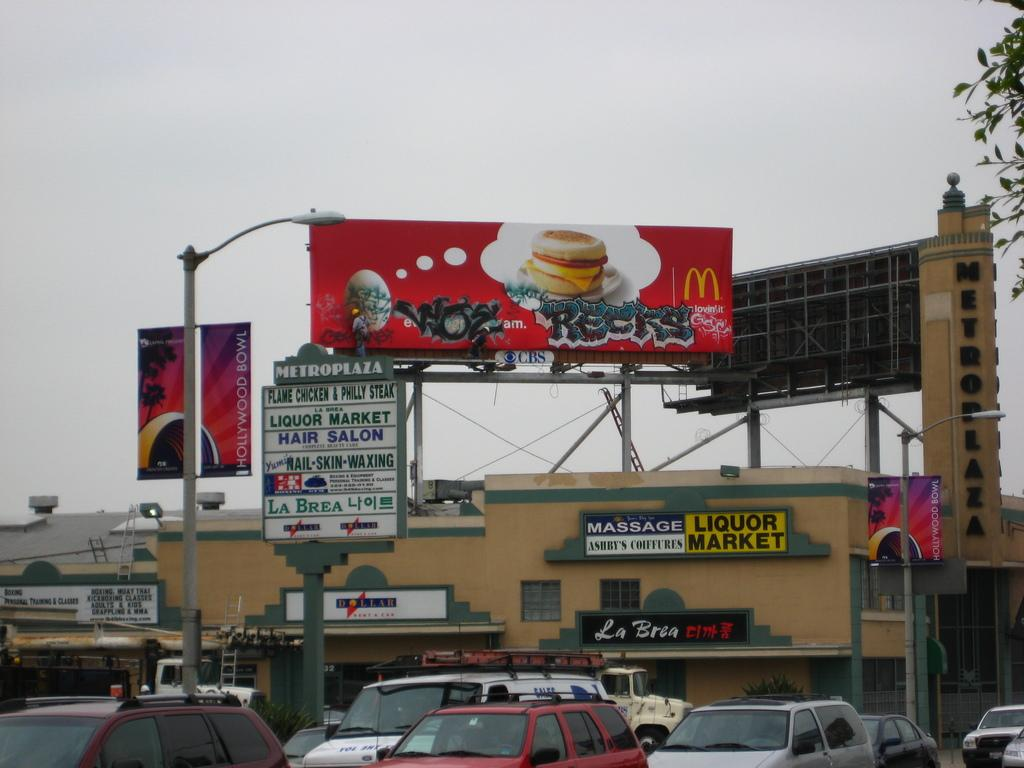Provide a one-sentence caption for the provided image. Above the Liquor Market there is a McDonald's billboard with graffiti across it. 